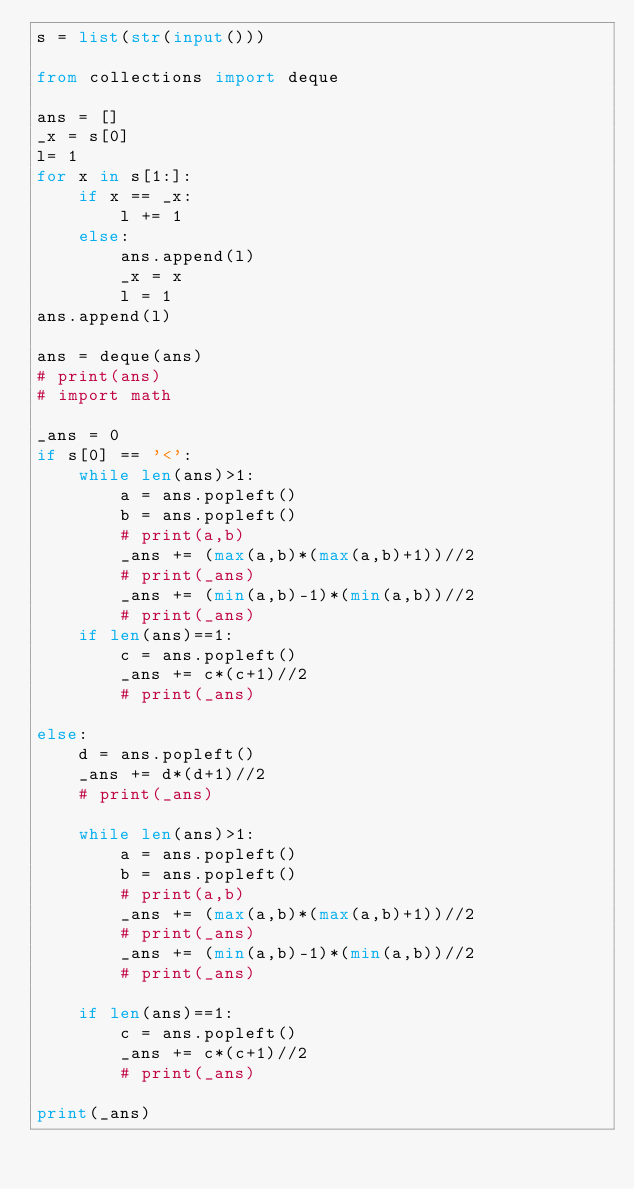Convert code to text. <code><loc_0><loc_0><loc_500><loc_500><_Python_>s = list(str(input()))

from collections import deque

ans = []
_x = s[0]
l= 1
for x in s[1:]:
    if x == _x:
        l += 1
    else:
        ans.append(l)
        _x = x
        l = 1
ans.append(l)

ans = deque(ans)
# print(ans)
# import math

_ans = 0
if s[0] == '<':
    while len(ans)>1:
        a = ans.popleft()
        b = ans.popleft()
        # print(a,b)
        _ans += (max(a,b)*(max(a,b)+1))//2
        # print(_ans)
        _ans += (min(a,b)-1)*(min(a,b))//2
        # print(_ans)
    if len(ans)==1:
        c = ans.popleft()
        _ans += c*(c+1)//2
        # print(_ans)

else:
    d = ans.popleft()
    _ans += d*(d+1)//2
    # print(_ans)

    while len(ans)>1:
        a = ans.popleft()
        b = ans.popleft()
        # print(a,b)
        _ans += (max(a,b)*(max(a,b)+1))//2
        # print(_ans)
        _ans += (min(a,b)-1)*(min(a,b))//2
        # print(_ans)

    if len(ans)==1:
        c = ans.popleft()
        _ans += c*(c+1)//2
        # print(_ans)

print(_ans)
</code> 